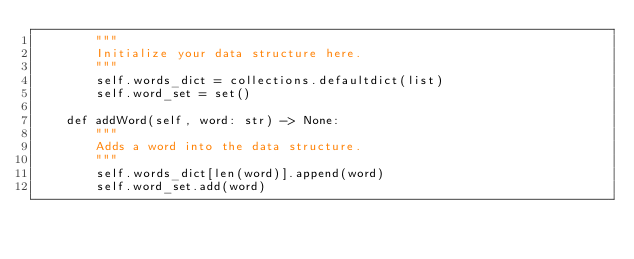Convert code to text. <code><loc_0><loc_0><loc_500><loc_500><_Python_>        """
        Initialize your data structure here.
        """
        self.words_dict = collections.defaultdict(list)
        self.word_set = set()

    def addWord(self, word: str) -> None:
        """
        Adds a word into the data structure.
        """
        self.words_dict[len(word)].append(word)
        self.word_set.add(word)
</code> 